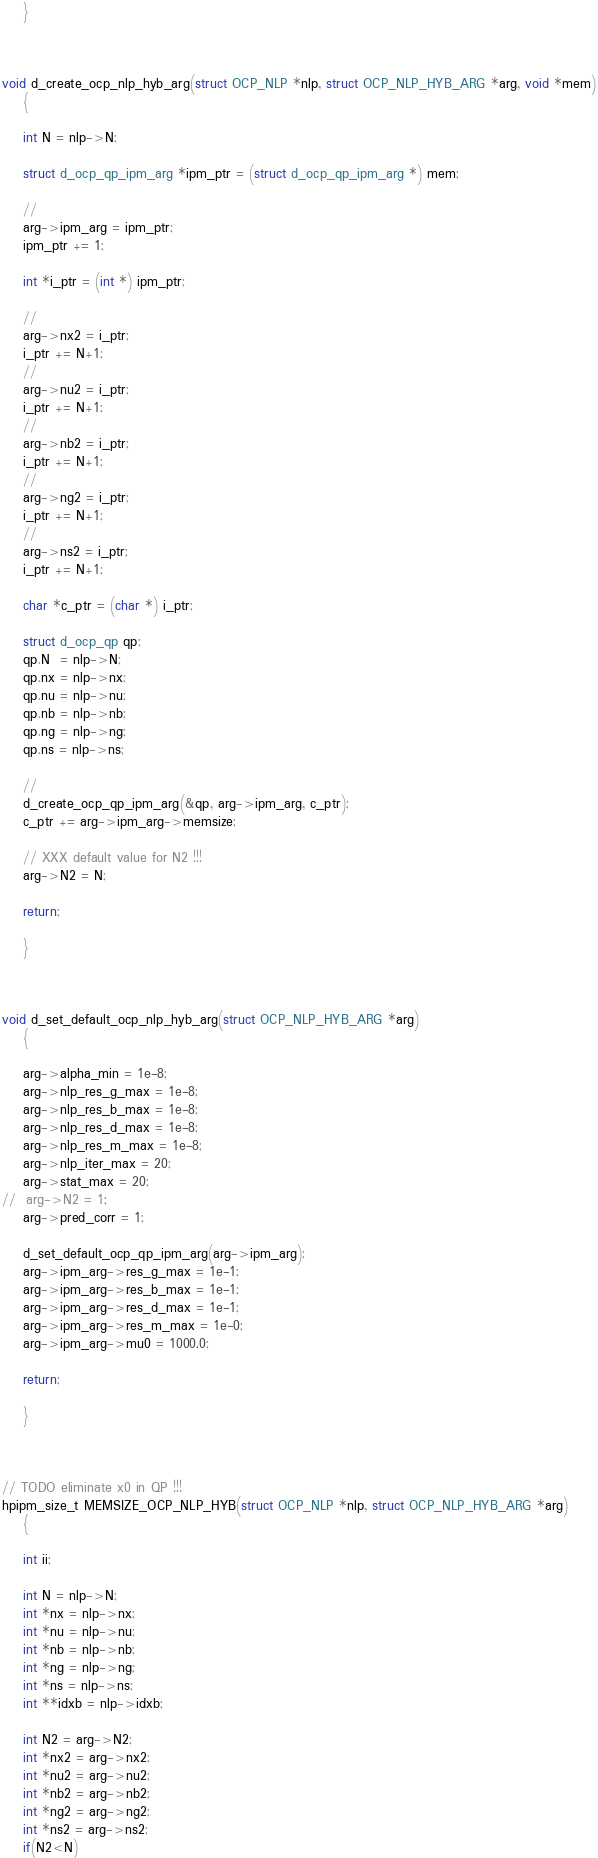<code> <loc_0><loc_0><loc_500><loc_500><_C_>
	}



void d_create_ocp_nlp_hyb_arg(struct OCP_NLP *nlp, struct OCP_NLP_HYB_ARG *arg, void *mem)
	{

	int N = nlp->N;

	struct d_ocp_qp_ipm_arg *ipm_ptr = (struct d_ocp_qp_ipm_arg *) mem;

	//
	arg->ipm_arg = ipm_ptr;
	ipm_ptr += 1;

	int *i_ptr = (int *) ipm_ptr;

	//
	arg->nx2 = i_ptr;
	i_ptr += N+1;
	//
	arg->nu2 = i_ptr;
	i_ptr += N+1;
	//
	arg->nb2 = i_ptr;
	i_ptr += N+1;
	//
	arg->ng2 = i_ptr;
	i_ptr += N+1;
	//
	arg->ns2 = i_ptr;
	i_ptr += N+1;

	char *c_ptr = (char *) i_ptr;

	struct d_ocp_qp qp;
	qp.N  = nlp->N;
	qp.nx = nlp->nx;
	qp.nu = nlp->nu;
	qp.nb = nlp->nb;
	qp.ng = nlp->ng;
	qp.ns = nlp->ns;

	//
	d_create_ocp_qp_ipm_arg(&qp, arg->ipm_arg, c_ptr);
	c_ptr += arg->ipm_arg->memsize;

	// XXX default value for N2 !!!
	arg->N2 = N; 

	return;

	}



void d_set_default_ocp_nlp_hyb_arg(struct OCP_NLP_HYB_ARG *arg)
	{

	arg->alpha_min = 1e-8;
	arg->nlp_res_g_max = 1e-8;
	arg->nlp_res_b_max = 1e-8;
	arg->nlp_res_d_max = 1e-8;
	arg->nlp_res_m_max = 1e-8;
	arg->nlp_iter_max = 20;
	arg->stat_max = 20;
//	arg->N2 = 1;
	arg->pred_corr = 1;

	d_set_default_ocp_qp_ipm_arg(arg->ipm_arg);
	arg->ipm_arg->res_g_max = 1e-1;
	arg->ipm_arg->res_b_max = 1e-1;
	arg->ipm_arg->res_d_max = 1e-1;
	arg->ipm_arg->res_m_max = 1e-0;
	arg->ipm_arg->mu0 = 1000.0;

	return;

	}



// TODO eliminate x0 in QP !!!
hpipm_size_t MEMSIZE_OCP_NLP_HYB(struct OCP_NLP *nlp, struct OCP_NLP_HYB_ARG *arg)
	{

	int ii;

	int N = nlp->N;
	int *nx = nlp->nx;
	int *nu = nlp->nu;
	int *nb = nlp->nb;
	int *ng = nlp->ng;
	int *ns = nlp->ns;
	int **idxb = nlp->idxb;

	int N2 = arg->N2;
	int *nx2 = arg->nx2;
	int *nu2 = arg->nu2;
	int *nb2 = arg->nb2;
	int *ng2 = arg->ng2;
	int *ns2 = arg->ns2;
	if(N2<N)</code> 